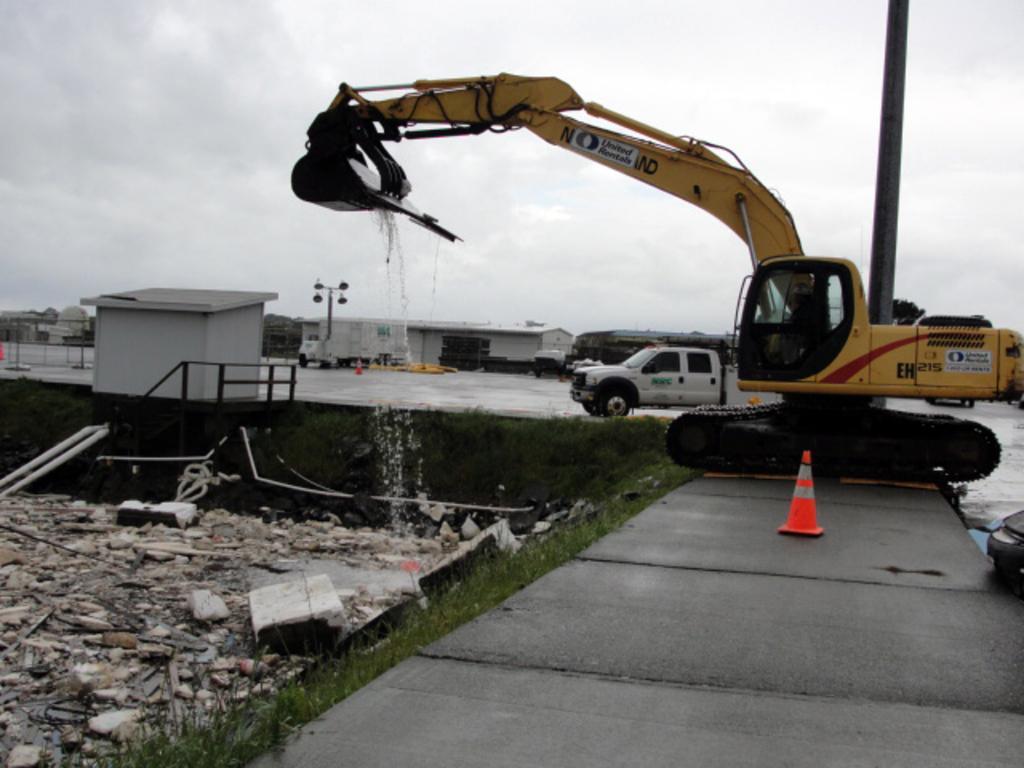Could you give a brief overview of what you see in this image? In this picture I can see houses and I can see a crane and a mini truck and I can see couple of pole lights and a cloudy sky and I can see a cone on the sidewalk. 